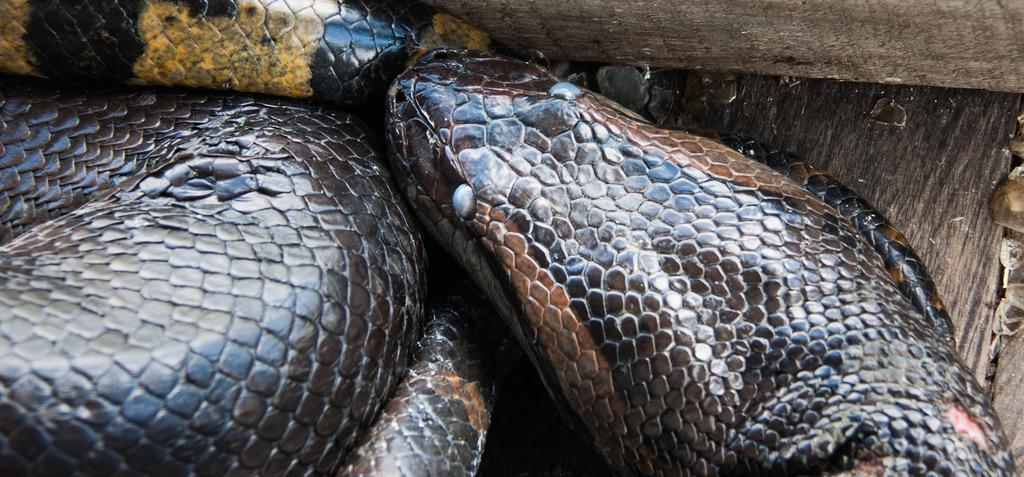What type of animal is present in the image? There is a snake in the image. Reasoning: Let's think step by step by step in order to produce the conversation. We start by identifying the main subject in the image, which is the snake. Since there is only one fact provided, we formulate a question that focuses on the type of animal present in the image. We avoid yes/no questions and ensure that the language is simple and clear. Absurd Question/Answer: What type of flame can be seen coming from the snake's mouth in the image? There is no flame present in the image, as it features a snake and flames are not a natural characteristic of snakes. Can you hear the cattle mooing in the background of the image? There is no mention of cattle or any sound in the image, as it features a snake and does not provide any information about the auditory environment. 